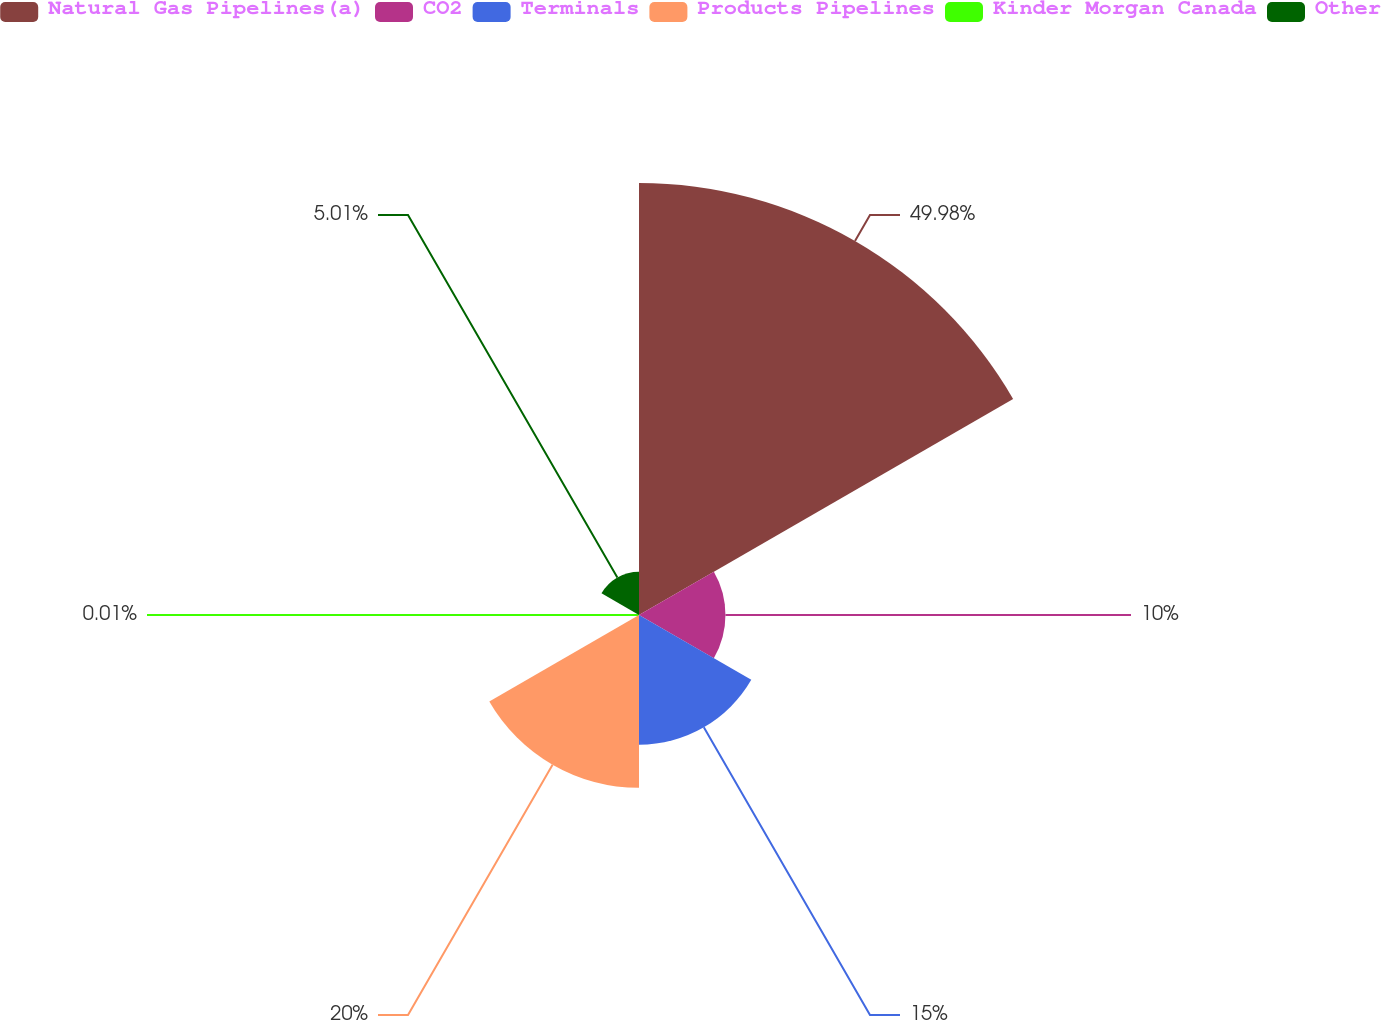Convert chart to OTSL. <chart><loc_0><loc_0><loc_500><loc_500><pie_chart><fcel>Natural Gas Pipelines(a)<fcel>CO2<fcel>Terminals<fcel>Products Pipelines<fcel>Kinder Morgan Canada<fcel>Other<nl><fcel>49.98%<fcel>10.0%<fcel>15.0%<fcel>20.0%<fcel>0.01%<fcel>5.01%<nl></chart> 